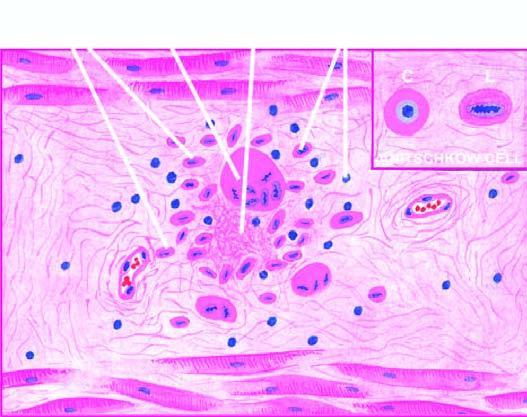does the tumour show anitschkow cell in longitudinal section with caterpillar-like serrated nuclear chromatin, while cross section cs shows owl-eye appearance of central chromatin mass and perinuclear halo?
Answer the question using a single word or phrase. No 